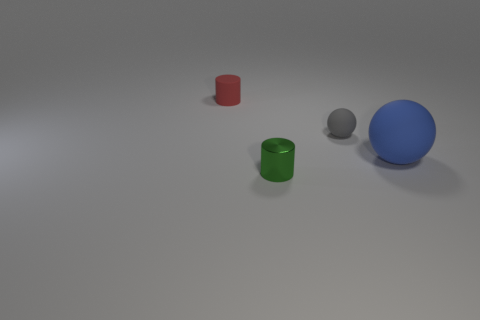Is there any other thing that is the same size as the blue rubber sphere?
Give a very brief answer. No. Is there any other thing that has the same material as the small green thing?
Keep it short and to the point. No. Does the large thing have the same color as the tiny cylinder right of the tiny red matte thing?
Ensure brevity in your answer.  No. Are there any small objects behind the large blue object?
Give a very brief answer. Yes. Is the green cylinder made of the same material as the blue sphere?
Your answer should be very brief. No. What is the material of the green thing that is the same size as the gray rubber object?
Offer a very short reply. Metal. What number of things are either spheres that are behind the blue ball or tiny yellow metal balls?
Your answer should be very brief. 1. Are there an equal number of small gray objects in front of the big ball and tiny gray spheres?
Keep it short and to the point. No. What is the color of the object that is left of the gray ball and behind the blue object?
Ensure brevity in your answer.  Red. How many cylinders are red objects or blue rubber things?
Offer a terse response. 1. 